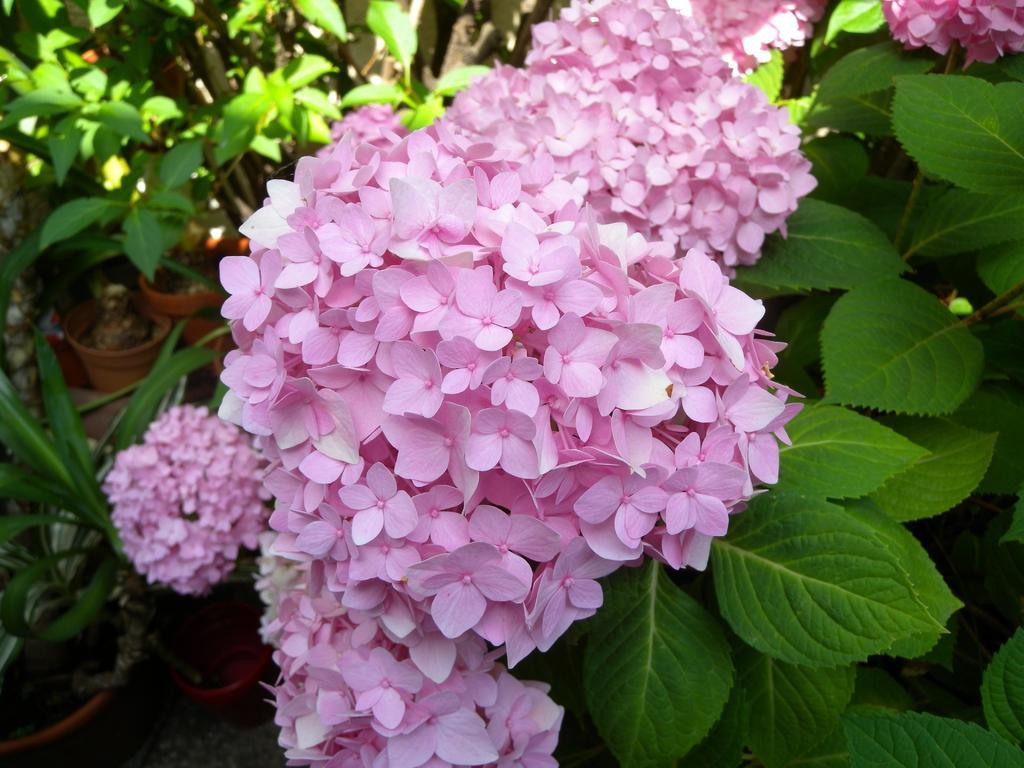Please provide a concise description of this image. The pink color flowers are highlighted in this picture. Around this pink flower there are number of plants in a pot. The leafs are in green color. 